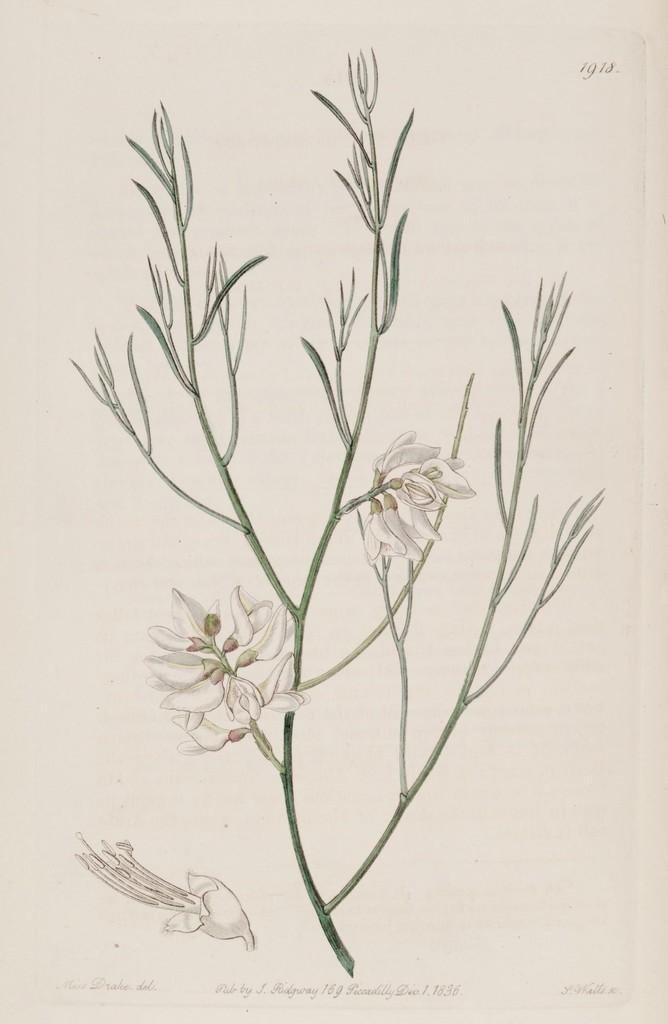What is the main subject of the image? There is an art piece in the image. What does the art piece depict? The art piece depicts a stem. What features are present on the stem? The stem has flowers and leaves. How many snails can be seen crawling on the stem in the image? There are no snails present in the image; the art piece depicts a stem with flowers and leaves. 